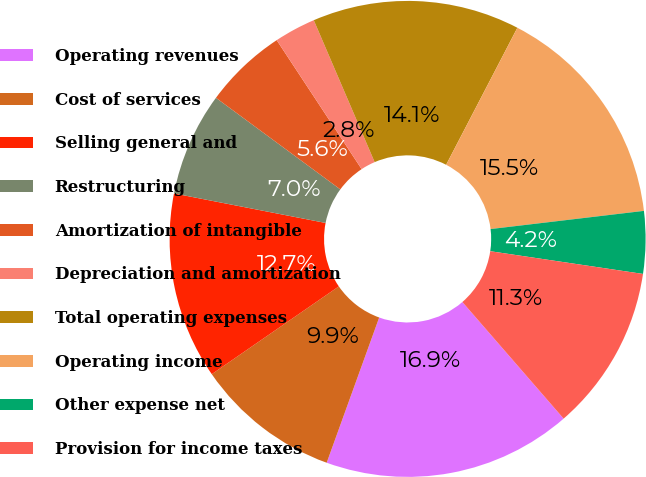Convert chart to OTSL. <chart><loc_0><loc_0><loc_500><loc_500><pie_chart><fcel>Operating revenues<fcel>Cost of services<fcel>Selling general and<fcel>Restructuring<fcel>Amortization of intangible<fcel>Depreciation and amortization<fcel>Total operating expenses<fcel>Operating income<fcel>Other expense net<fcel>Provision for income taxes<nl><fcel>16.9%<fcel>9.86%<fcel>12.68%<fcel>7.04%<fcel>5.63%<fcel>2.82%<fcel>14.08%<fcel>15.49%<fcel>4.23%<fcel>11.27%<nl></chart> 